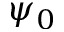<formula> <loc_0><loc_0><loc_500><loc_500>\psi _ { 0 }</formula> 